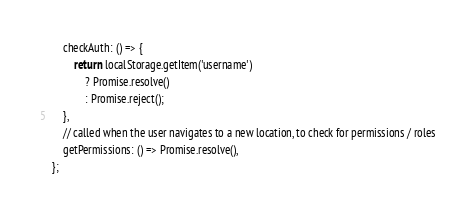Convert code to text. <code><loc_0><loc_0><loc_500><loc_500><_JavaScript_>    checkAuth: () => {
        return localStorage.getItem('username')
            ? Promise.resolve()
            : Promise.reject();
    },
    // called when the user navigates to a new location, to check for permissions / roles
    getPermissions: () => Promise.resolve(),
};
</code> 